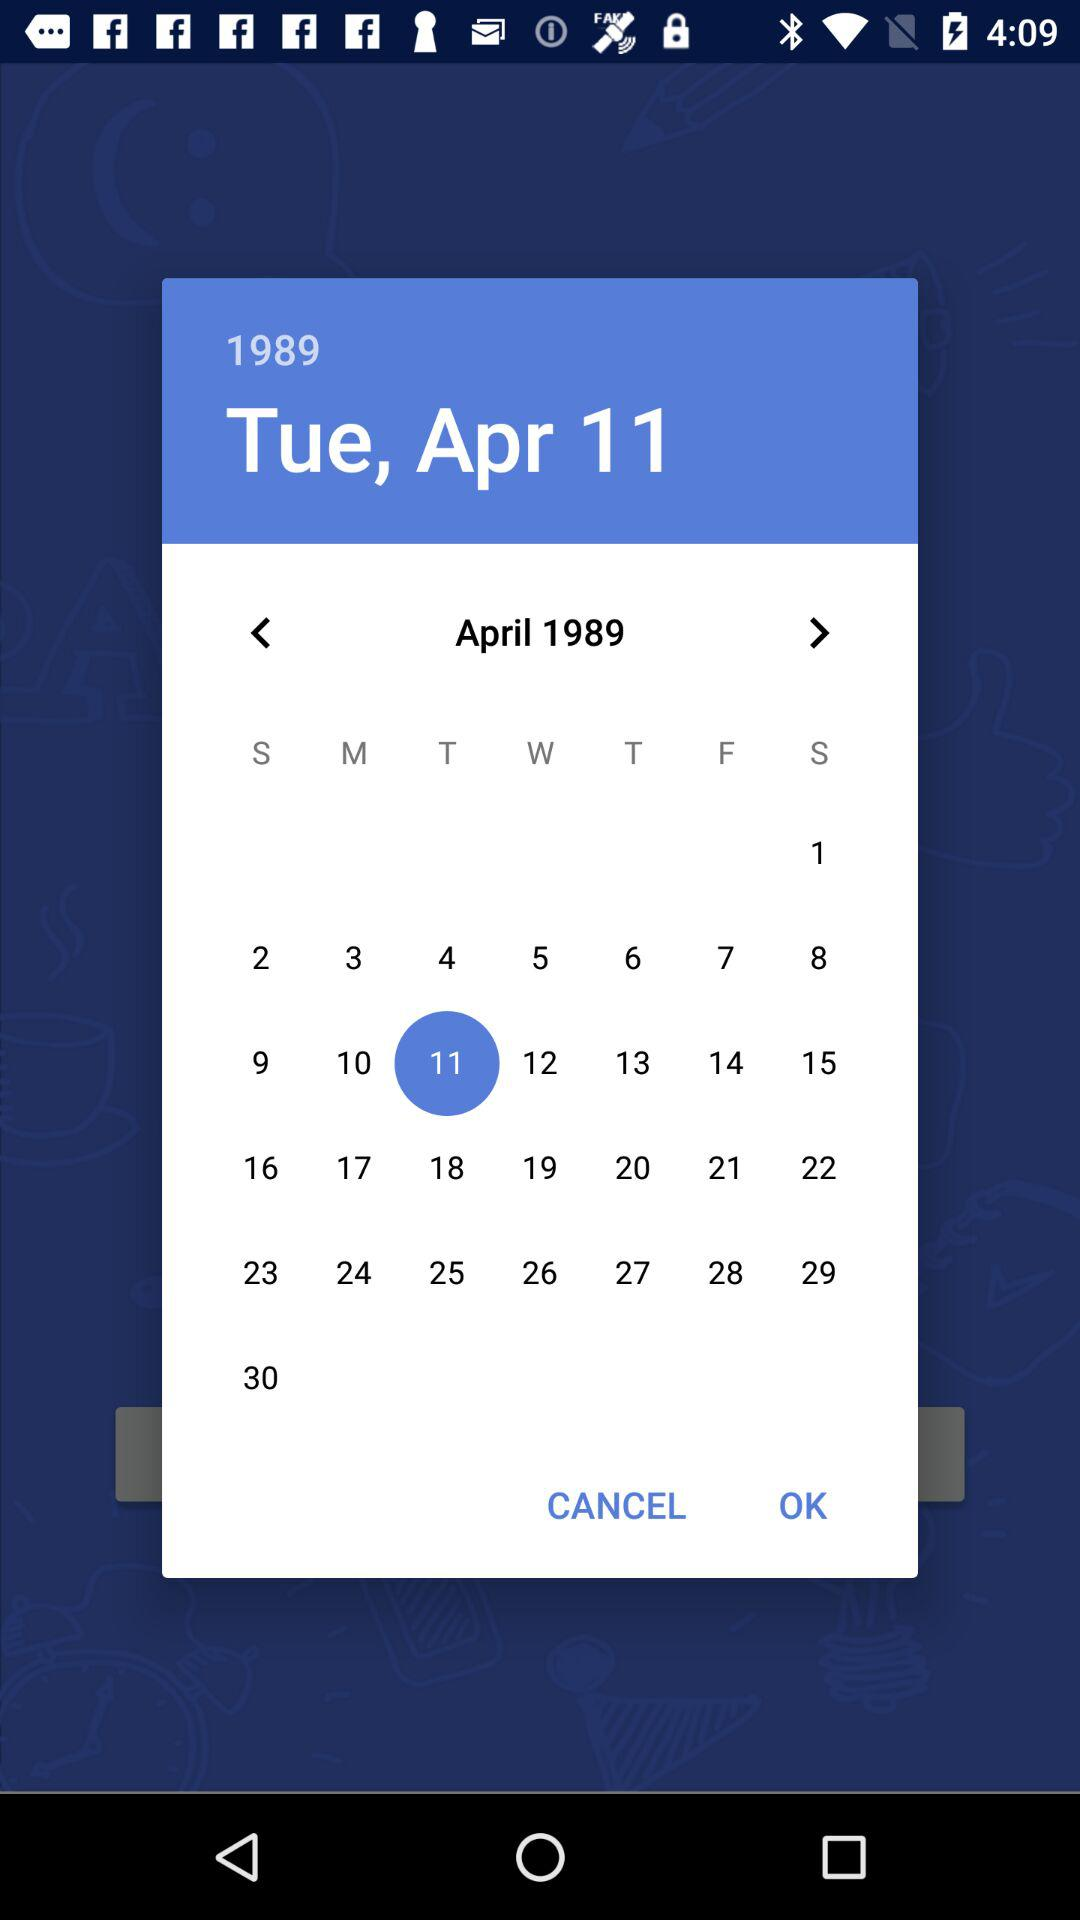What is the selected date? The selected day is Tuesday, April 11, 1989. 